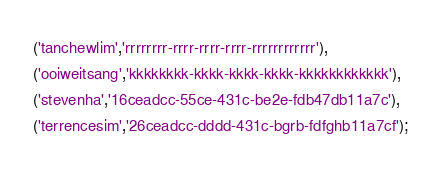<code> <loc_0><loc_0><loc_500><loc_500><_SQL_>('tanchewlim','rrrrrrrr-rrrr-rrrr-rrrr-rrrrrrrrrrrr'),
('ooiweitsang','kkkkkkkk-kkkk-kkkk-kkkk-kkkkkkkkkkkk'),
('stevenha','16ceadcc-55ce-431c-be2e-fdb47db11a7c'),
('terrencesim','26ceadcc-dddd-431c-bgrb-fdfghb11a7cf');</code> 